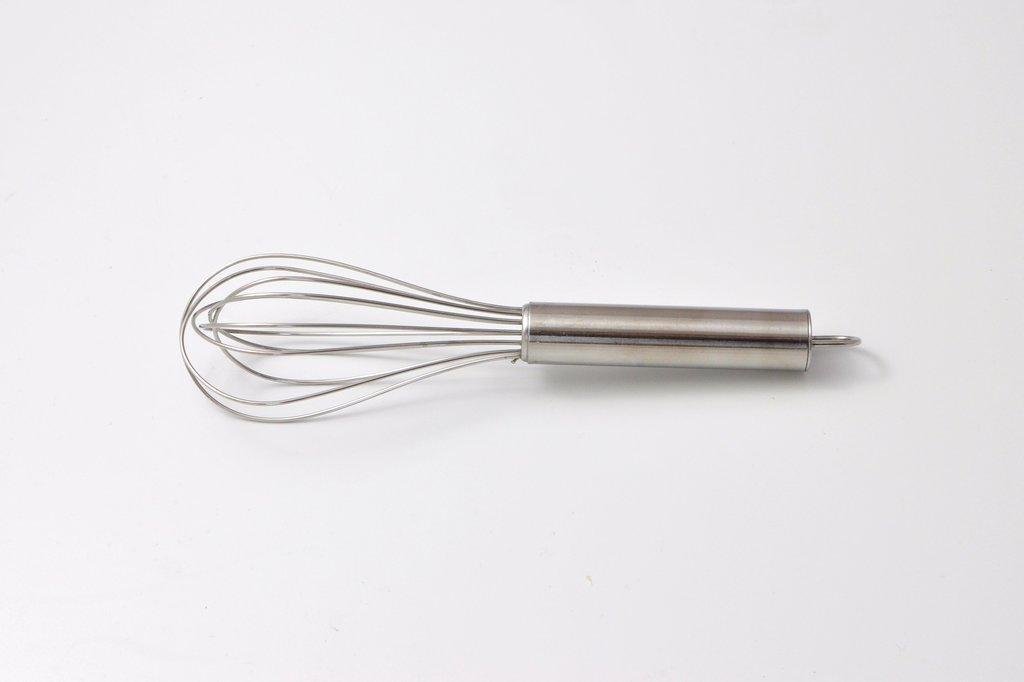Please provide a concise description of this image. In the center of this picture we can see a whisk and the background of the image is white in color. 